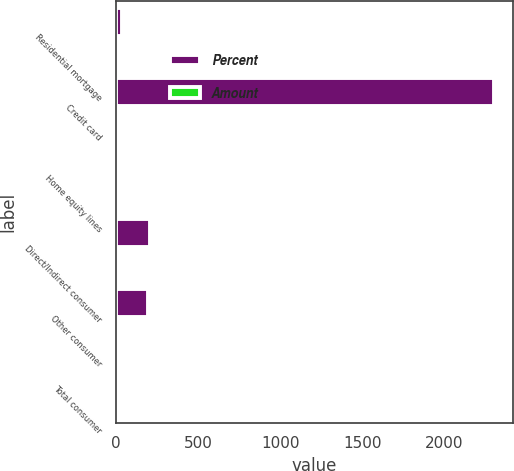Convert chart to OTSL. <chart><loc_0><loc_0><loc_500><loc_500><stacked_bar_chart><ecel><fcel>Residential mortgage<fcel>Credit card<fcel>Home equity lines<fcel>Direct/Indirect consumer<fcel>Other consumer<fcel>Total consumer<nl><fcel>Percent<fcel>36<fcel>2305<fcel>15<fcel>208<fcel>193<fcel>5.31<nl><fcel>Amount<fcel>0.02<fcel>5.31<fcel>0.04<fcel>0.55<fcel>2.51<fcel>0.93<nl></chart> 